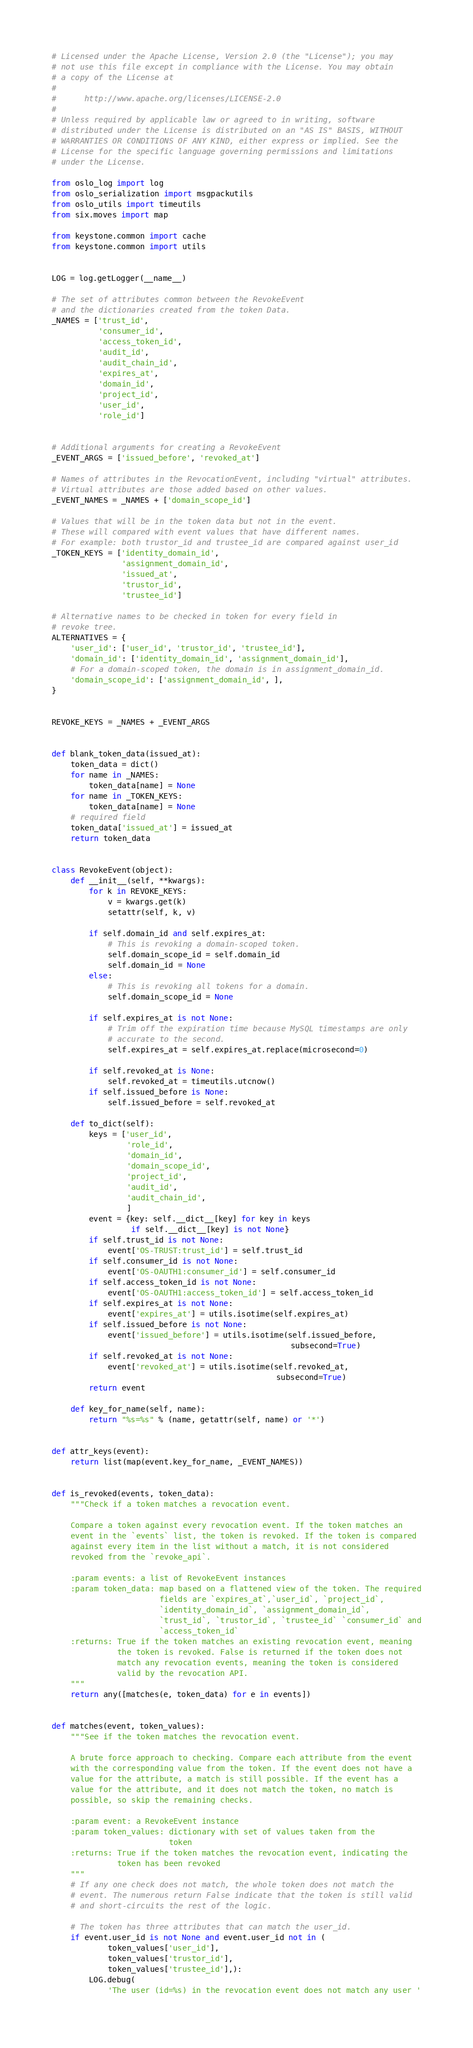Convert code to text. <code><loc_0><loc_0><loc_500><loc_500><_Python_># Licensed under the Apache License, Version 2.0 (the "License"); you may
# not use this file except in compliance with the License. You may obtain
# a copy of the License at
#
#      http://www.apache.org/licenses/LICENSE-2.0
#
# Unless required by applicable law or agreed to in writing, software
# distributed under the License is distributed on an "AS IS" BASIS, WITHOUT
# WARRANTIES OR CONDITIONS OF ANY KIND, either express or implied. See the
# License for the specific language governing permissions and limitations
# under the License.

from oslo_log import log
from oslo_serialization import msgpackutils
from oslo_utils import timeutils
from six.moves import map

from keystone.common import cache
from keystone.common import utils


LOG = log.getLogger(__name__)

# The set of attributes common between the RevokeEvent
# and the dictionaries created from the token Data.
_NAMES = ['trust_id',
          'consumer_id',
          'access_token_id',
          'audit_id',
          'audit_chain_id',
          'expires_at',
          'domain_id',
          'project_id',
          'user_id',
          'role_id']


# Additional arguments for creating a RevokeEvent
_EVENT_ARGS = ['issued_before', 'revoked_at']

# Names of attributes in the RevocationEvent, including "virtual" attributes.
# Virtual attributes are those added based on other values.
_EVENT_NAMES = _NAMES + ['domain_scope_id']

# Values that will be in the token data but not in the event.
# These will compared with event values that have different names.
# For example: both trustor_id and trustee_id are compared against user_id
_TOKEN_KEYS = ['identity_domain_id',
               'assignment_domain_id',
               'issued_at',
               'trustor_id',
               'trustee_id']

# Alternative names to be checked in token for every field in
# revoke tree.
ALTERNATIVES = {
    'user_id': ['user_id', 'trustor_id', 'trustee_id'],
    'domain_id': ['identity_domain_id', 'assignment_domain_id'],
    # For a domain-scoped token, the domain is in assignment_domain_id.
    'domain_scope_id': ['assignment_domain_id', ],
}


REVOKE_KEYS = _NAMES + _EVENT_ARGS


def blank_token_data(issued_at):
    token_data = dict()
    for name in _NAMES:
        token_data[name] = None
    for name in _TOKEN_KEYS:
        token_data[name] = None
    # required field
    token_data['issued_at'] = issued_at
    return token_data


class RevokeEvent(object):
    def __init__(self, **kwargs):
        for k in REVOKE_KEYS:
            v = kwargs.get(k)
            setattr(self, k, v)

        if self.domain_id and self.expires_at:
            # This is revoking a domain-scoped token.
            self.domain_scope_id = self.domain_id
            self.domain_id = None
        else:
            # This is revoking all tokens for a domain.
            self.domain_scope_id = None

        if self.expires_at is not None:
            # Trim off the expiration time because MySQL timestamps are only
            # accurate to the second.
            self.expires_at = self.expires_at.replace(microsecond=0)

        if self.revoked_at is None:
            self.revoked_at = timeutils.utcnow()
        if self.issued_before is None:
            self.issued_before = self.revoked_at

    def to_dict(self):
        keys = ['user_id',
                'role_id',
                'domain_id',
                'domain_scope_id',
                'project_id',
                'audit_id',
                'audit_chain_id',
                ]
        event = {key: self.__dict__[key] for key in keys
                 if self.__dict__[key] is not None}
        if self.trust_id is not None:
            event['OS-TRUST:trust_id'] = self.trust_id
        if self.consumer_id is not None:
            event['OS-OAUTH1:consumer_id'] = self.consumer_id
        if self.access_token_id is not None:
            event['OS-OAUTH1:access_token_id'] = self.access_token_id
        if self.expires_at is not None:
            event['expires_at'] = utils.isotime(self.expires_at)
        if self.issued_before is not None:
            event['issued_before'] = utils.isotime(self.issued_before,
                                                   subsecond=True)
        if self.revoked_at is not None:
            event['revoked_at'] = utils.isotime(self.revoked_at,
                                                subsecond=True)
        return event

    def key_for_name(self, name):
        return "%s=%s" % (name, getattr(self, name) or '*')


def attr_keys(event):
    return list(map(event.key_for_name, _EVENT_NAMES))


def is_revoked(events, token_data):
    """Check if a token matches a revocation event.

    Compare a token against every revocation event. If the token matches an
    event in the `events` list, the token is revoked. If the token is compared
    against every item in the list without a match, it is not considered
    revoked from the `revoke_api`.

    :param events: a list of RevokeEvent instances
    :param token_data: map based on a flattened view of the token. The required
                       fields are `expires_at`,`user_id`, `project_id`,
                       `identity_domain_id`, `assignment_domain_id`,
                       `trust_id`, `trustor_id`, `trustee_id` `consumer_id` and
                       `access_token_id`
    :returns: True if the token matches an existing revocation event, meaning
              the token is revoked. False is returned if the token does not
              match any revocation events, meaning the token is considered
              valid by the revocation API.
    """
    return any([matches(e, token_data) for e in events])


def matches(event, token_values):
    """See if the token matches the revocation event.

    A brute force approach to checking. Compare each attribute from the event
    with the corresponding value from the token. If the event does not have a
    value for the attribute, a match is still possible. If the event has a
    value for the attribute, and it does not match the token, no match is
    possible, so skip the remaining checks.

    :param event: a RevokeEvent instance
    :param token_values: dictionary with set of values taken from the
                         token
    :returns: True if the token matches the revocation event, indicating the
              token has been revoked
    """
    # If any one check does not match, the whole token does not match the
    # event. The numerous return False indicate that the token is still valid
    # and short-circuits the rest of the logic.

    # The token has three attributes that can match the user_id.
    if event.user_id is not None and event.user_id not in (
            token_values['user_id'],
            token_values['trustor_id'],
            token_values['trustee_id'],):
        LOG.debug(
            'The user (id=%s) in the revocation event does not match any user '</code> 